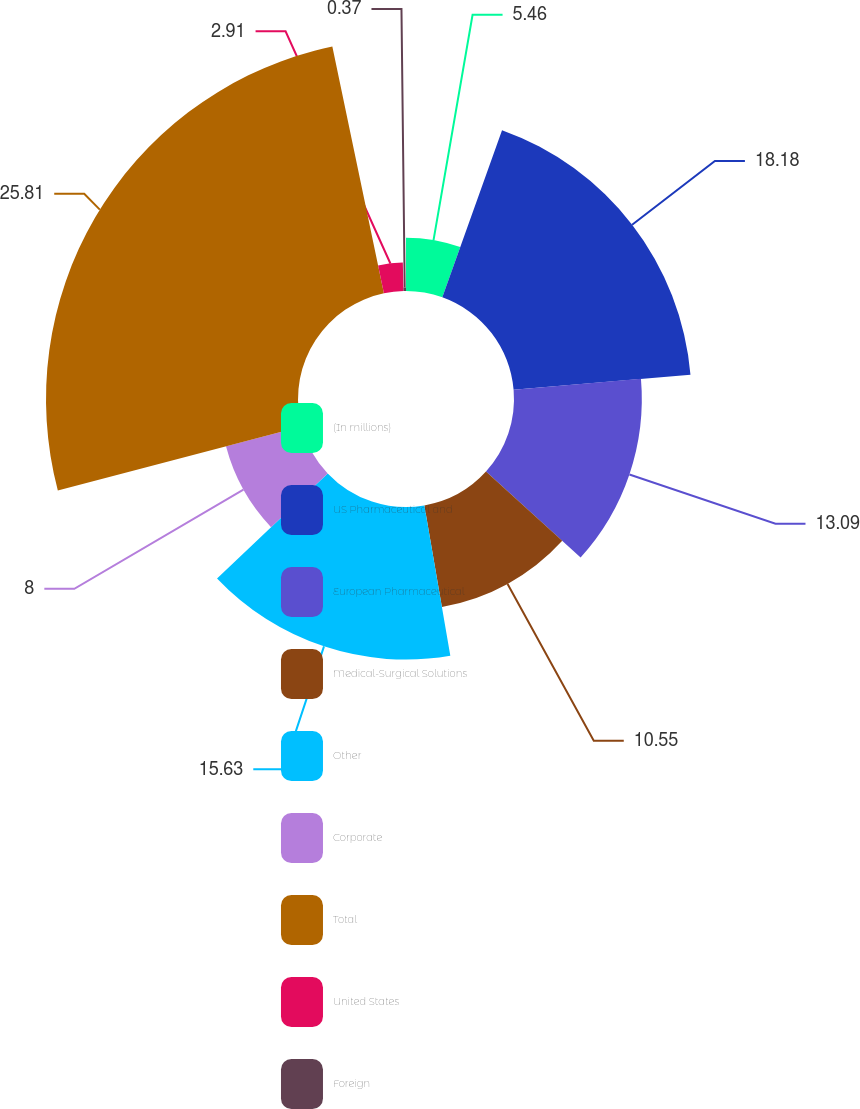Convert chart to OTSL. <chart><loc_0><loc_0><loc_500><loc_500><pie_chart><fcel>(In millions)<fcel>US Pharmaceutical and<fcel>European Pharmaceutical<fcel>Medical-Surgical Solutions<fcel>Other<fcel>Corporate<fcel>Total<fcel>United States<fcel>Foreign<nl><fcel>5.46%<fcel>18.18%<fcel>13.09%<fcel>10.55%<fcel>15.63%<fcel>8.0%<fcel>25.81%<fcel>2.91%<fcel>0.37%<nl></chart> 